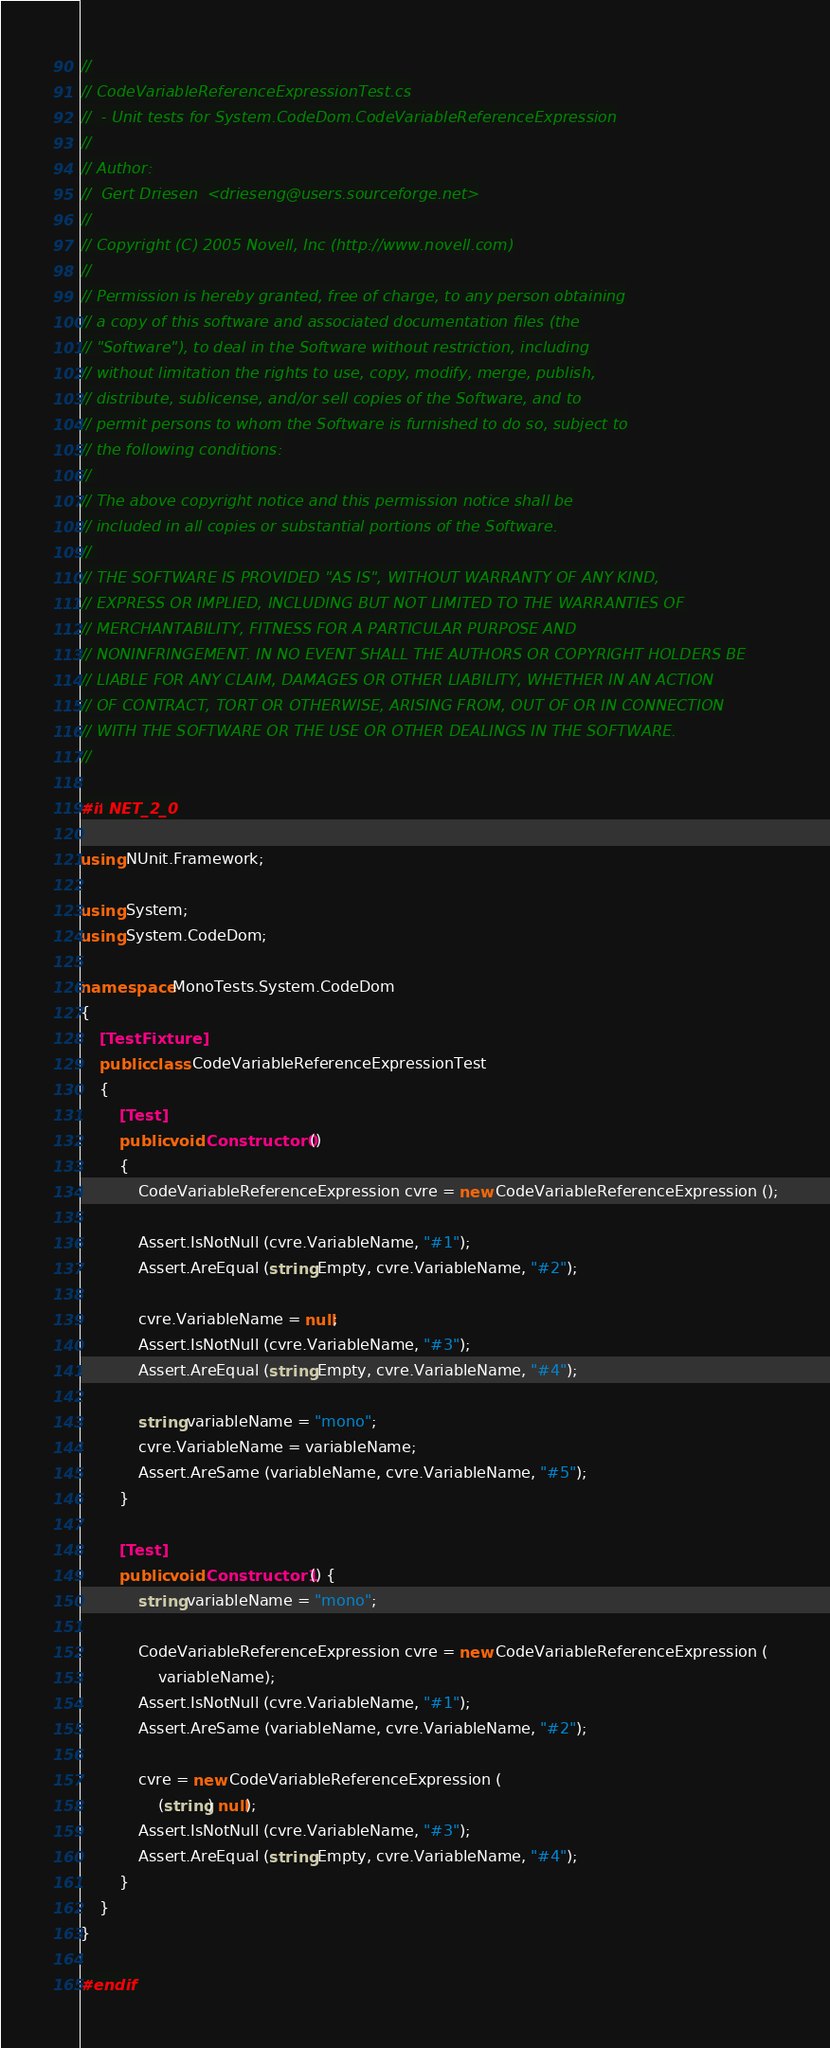Convert code to text. <code><loc_0><loc_0><loc_500><loc_500><_C#_>//
// CodeVariableReferenceExpressionTest.cs
//	- Unit tests for System.CodeDom.CodeVariableReferenceExpression
//
// Author:
//	Gert Driesen  <drieseng@users.sourceforge.net>
//
// Copyright (C) 2005 Novell, Inc (http://www.novell.com)
//
// Permission is hereby granted, free of charge, to any person obtaining
// a copy of this software and associated documentation files (the
// "Software"), to deal in the Software without restriction, including
// without limitation the rights to use, copy, modify, merge, publish,
// distribute, sublicense, and/or sell copies of the Software, and to
// permit persons to whom the Software is furnished to do so, subject to
// the following conditions:
// 
// The above copyright notice and this permission notice shall be
// included in all copies or substantial portions of the Software.
// 
// THE SOFTWARE IS PROVIDED "AS IS", WITHOUT WARRANTY OF ANY KIND,
// EXPRESS OR IMPLIED, INCLUDING BUT NOT LIMITED TO THE WARRANTIES OF
// MERCHANTABILITY, FITNESS FOR A PARTICULAR PURPOSE AND
// NONINFRINGEMENT. IN NO EVENT SHALL THE AUTHORS OR COPYRIGHT HOLDERS BE
// LIABLE FOR ANY CLAIM, DAMAGES OR OTHER LIABILITY, WHETHER IN AN ACTION
// OF CONTRACT, TORT OR OTHERWISE, ARISING FROM, OUT OF OR IN CONNECTION
// WITH THE SOFTWARE OR THE USE OR OTHER DEALINGS IN THE SOFTWARE.
//

#if NET_2_0

using NUnit.Framework;

using System;
using System.CodeDom;

namespace MonoTests.System.CodeDom
{
	[TestFixture]
	public class CodeVariableReferenceExpressionTest
	{
		[Test]
		public void Constructor0 ()
		{
			CodeVariableReferenceExpression cvre = new CodeVariableReferenceExpression ();

			Assert.IsNotNull (cvre.VariableName, "#1");
			Assert.AreEqual (string.Empty, cvre.VariableName, "#2");

			cvre.VariableName = null;
			Assert.IsNotNull (cvre.VariableName, "#3");
			Assert.AreEqual (string.Empty, cvre.VariableName, "#4");

			string variableName = "mono";
			cvre.VariableName = variableName;
			Assert.AreSame (variableName, cvre.VariableName, "#5");
		}

		[Test]
		public void Constructor1 () {
			string variableName = "mono";

			CodeVariableReferenceExpression cvre = new CodeVariableReferenceExpression (
				variableName);
			Assert.IsNotNull (cvre.VariableName, "#1");
			Assert.AreSame (variableName, cvre.VariableName, "#2");

			cvre = new CodeVariableReferenceExpression (
				(string) null);
			Assert.IsNotNull (cvre.VariableName, "#3");
			Assert.AreEqual (string.Empty, cvre.VariableName, "#4");
		}
	}
}

#endif
</code> 